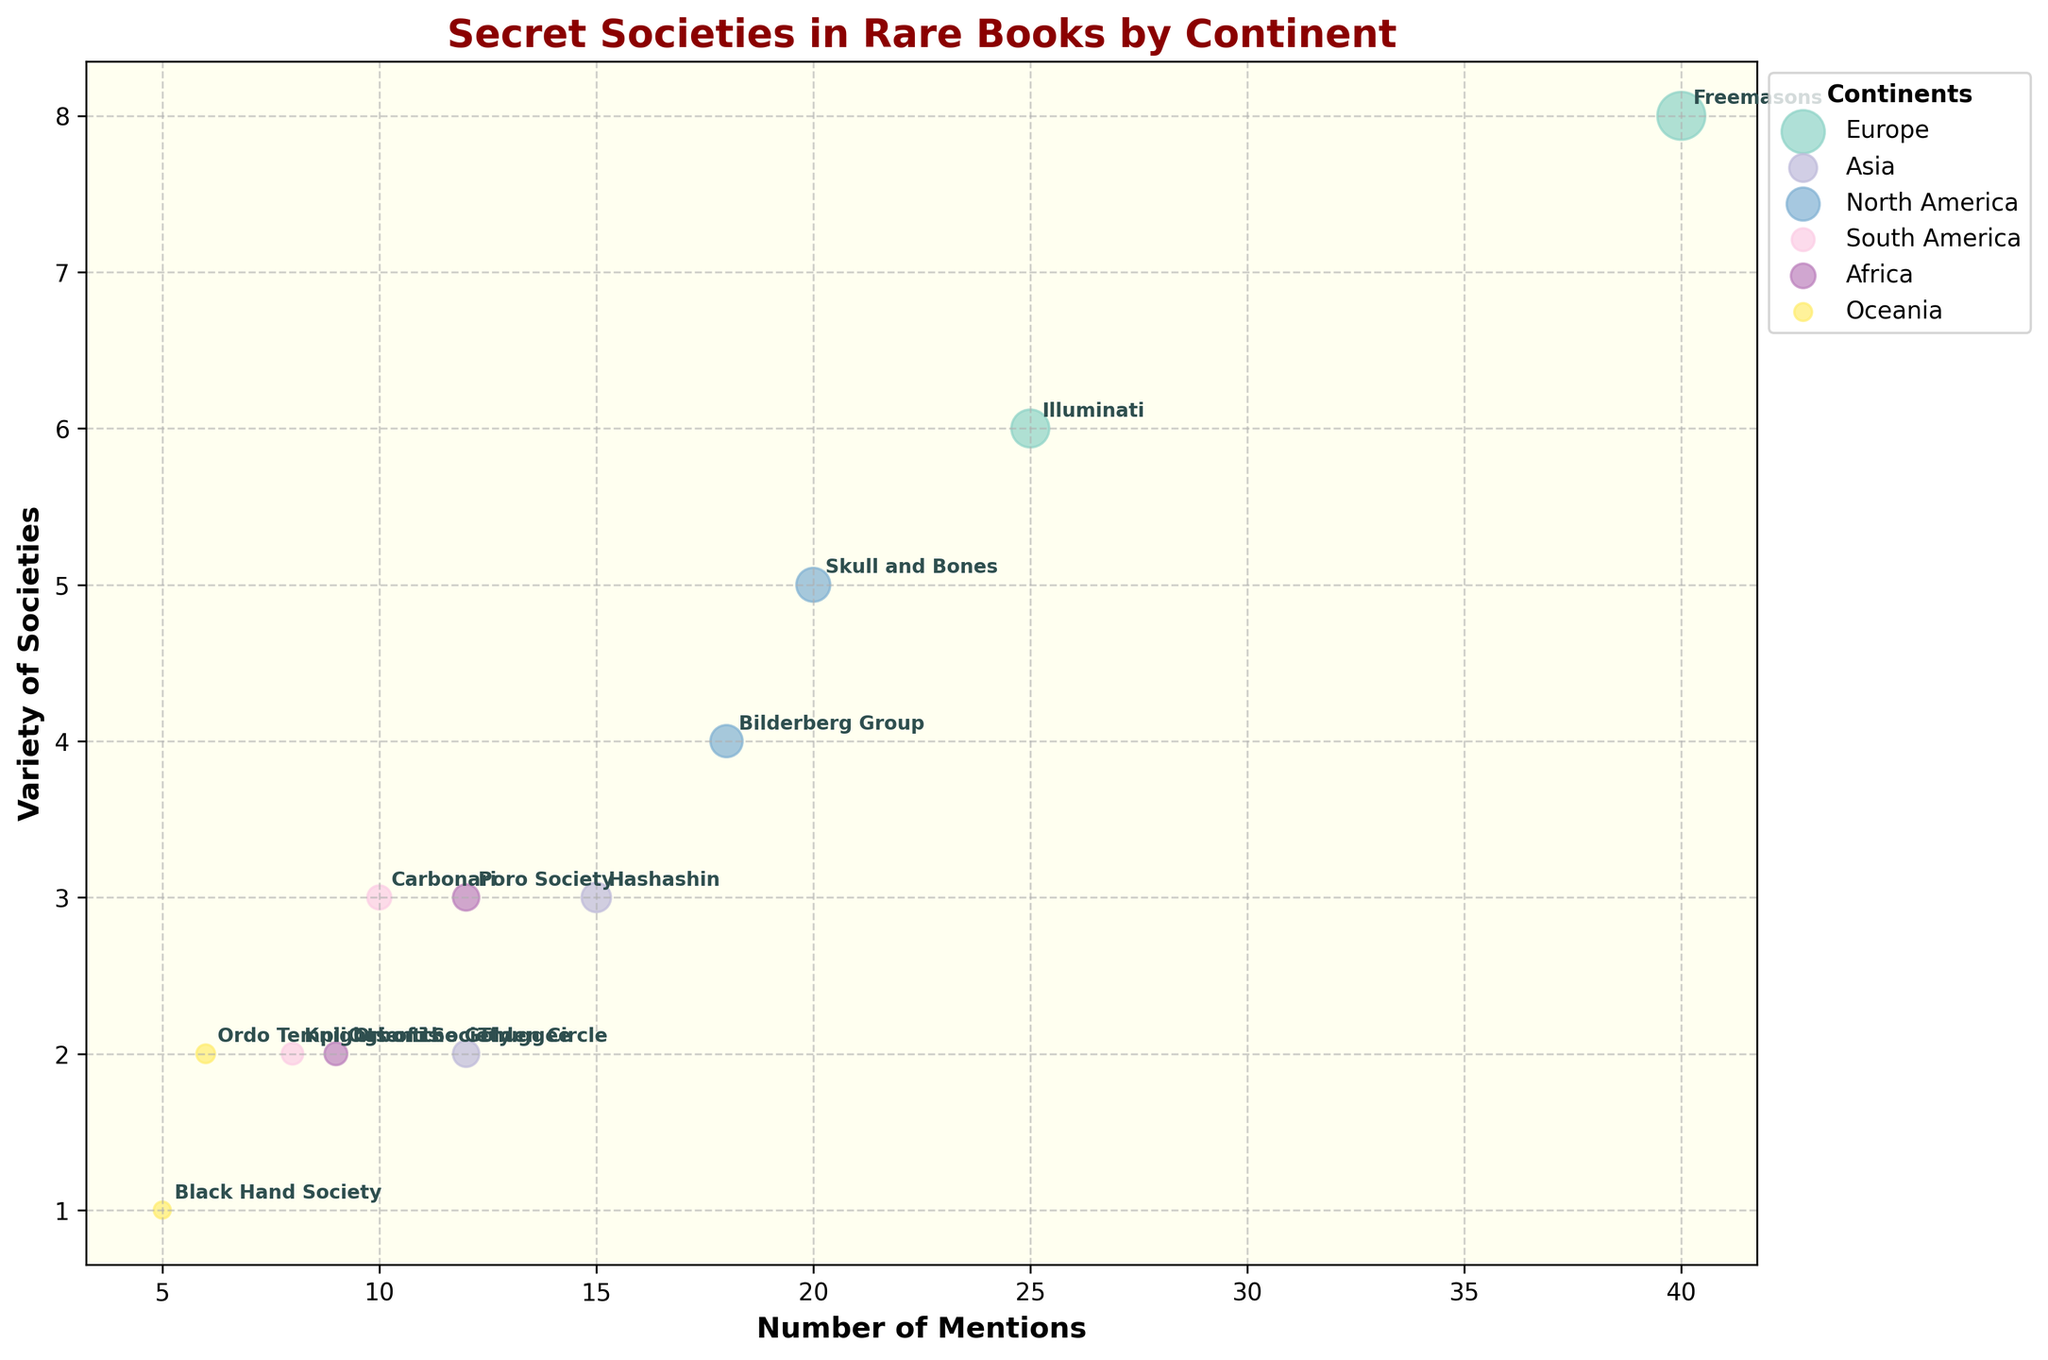What is the title of the chart? The title of the chart is usually found above the main plotting area. In this figure, it can be directly read from the plot's title section.
Answer: Secret Societies in Rare Books by Continent Which continent has the most mentions of secret societies? By examining the number of mentions associated with each continent's data points, Europe stands out with the highest individual mentions for both Illuminati (25) and Freemasons (40).
Answer: Europe How many secret societies are mentioned in North America, and what is the total number of mentions? Summing the number of mentions for secret societies in North America (Skull and Bones: 20, Bilderberg Group: 18) results in a total of 38 mentions.
Answer: 38 Which secret society has the highest variety within its continent, and what is that variety? The Freemasons in Europe have the highest variety of societies, with a value of 8, as seen from the vertical position of their bubble.
Answer: Freemasons, 8 What is the average number of mentions for the secret societies in Asia? Asia has two secret societies: Hashashin (15 mentions) and Thuggee (12 mentions). The average is calculated as (15 + 12) / 2 = 13.5 mentions.
Answer: 13.5 Which continent contains the secret society with the smallest number of mentions, and what is the name of that society? The smallest number of mentions can be identified by the smallest labeled bubble, which is the Black Hand Society in Oceania with 5 mentions.
Answer: Oceania, Black Hand Society Compare the number of mentions of 'Poro Society' in Africa and 'Carbonari' in South America. Which one is greater? Comparing their respective mentions, Poro Society has 12 mentions while Carbonari has 10 mentions, making Poro Society greater.
Answer: Poro Society How many secret societies have a variety of 2? By counting bubbles positioned at the Variety of Societies value of 2, the secret societies are Thuggee, Knights of the Golden Circle, Ogboni Society, and Ordo Templi Orientis, totaling 4.
Answer: 4 What is the combined variety of societies mentioned in South America? South America has Carbonari (3 variaties) and Knights of the Golden Circle (2 varieties). Their combined variety is 3 + 2 = 5.
Answer: 5 Which continent represents the most secret societies in this plot? Counting distinct secret societies per continent from the labels, Europe and North America tie with 2 each.
Answer: Europe, North America 